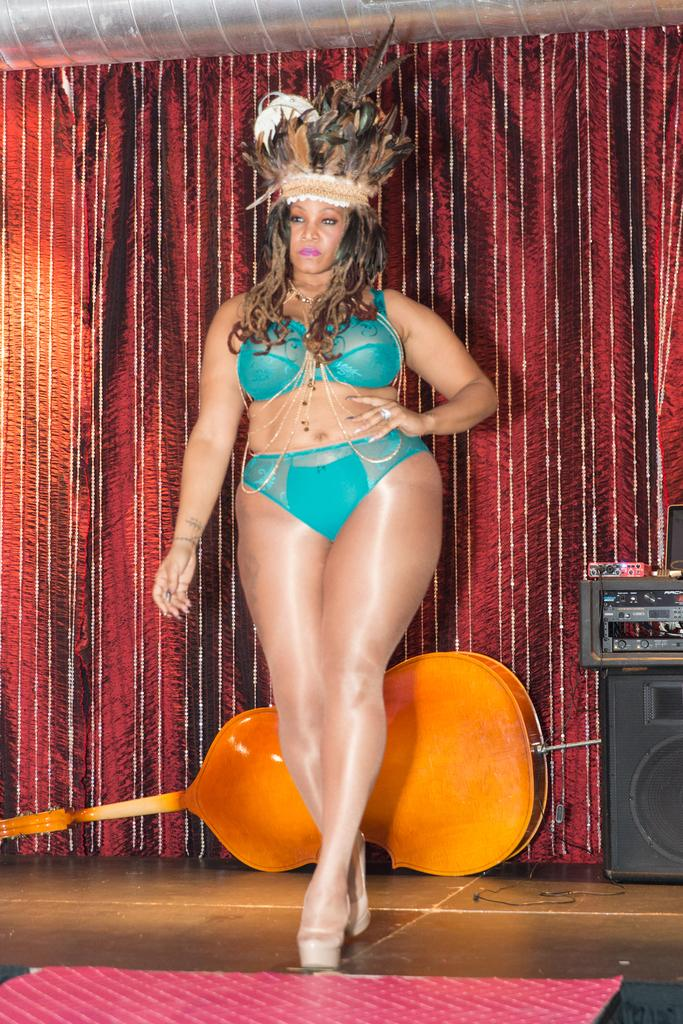What is the main subject of the image? There is a woman standing in the image. What can be seen in the background of the image? There is a musical instrument, a speaker, devices, a curtain, and some objects in the background of the image. Can you describe the musical instrument in the background? Unfortunately, the specific type of musical instrument cannot be determined from the provided facts. What type of rice is being cooked in the image? There is no rice present in the image. What is the zephyr's role in the image? There is no zephyr mentioned or depicted in the image. 